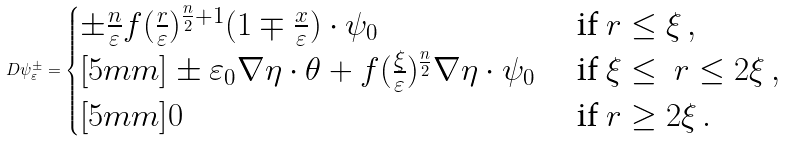<formula> <loc_0><loc_0><loc_500><loc_500>D \psi _ { \varepsilon } ^ { \pm } = \begin{cases} \pm \frac { n } { \varepsilon } f ( \frac { r } { \varepsilon } ) ^ { \frac { n } { 2 } + 1 } ( 1 \mp \frac { x } { \varepsilon } ) \cdot \psi _ { 0 } & \text { if } r \leq \xi \, , \\ [ 5 m m ] \pm \varepsilon _ { 0 } \nabla \eta \cdot \theta + f ( \frac { \xi } { \varepsilon } ) ^ { \frac { n } { 2 } } \nabla \eta \cdot \psi _ { 0 } & \text { if } \xi \leq \ r \leq 2 \xi \, , \\ [ 5 m m ] 0 & \text { if } r \geq 2 \xi \, . \end{cases}</formula> 